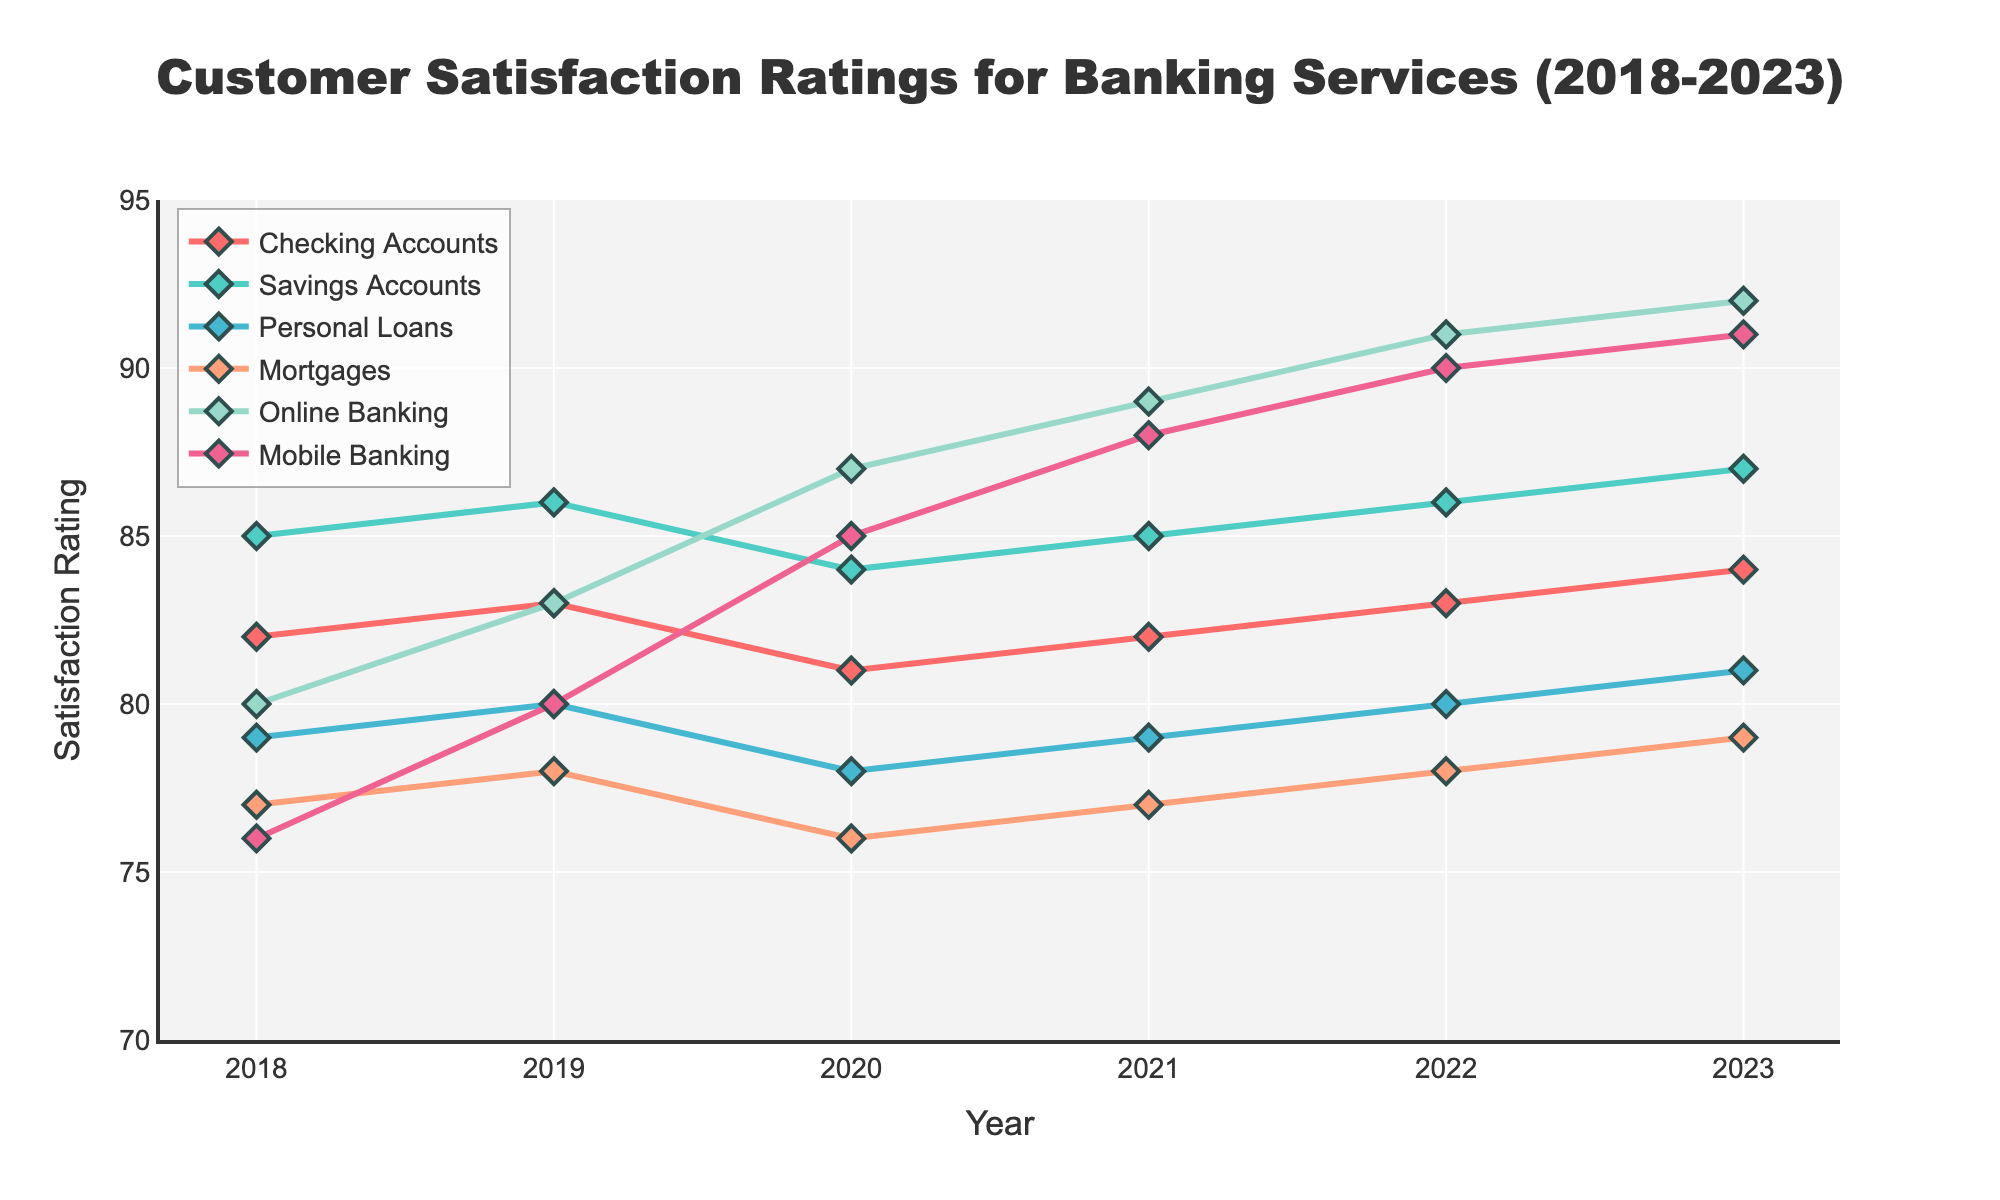What is the satisfaction rating for Online Banking in 2020? Look for the data point corresponding to Online Banking in 2020 in the chart. The rating is 87.
Answer: 87 Which service had the highest satisfaction rating in 2023? Examine the ratings for all services in 2023; the highest value is for Online Banking with a rating of 92.
Answer: Online Banking How much did the satisfaction rating for Personal Loans change from 2018 to 2023? Subtract the rating in 2018 (79) from the rating in 2023 (81). The change is 81 - 79 = 2.
Answer: 2 Which service experienced the largest increase in customer satisfaction from 2018 to 2023? Calculate the difference for each service between 2023 and 2018, then determine the largest increase. Online Banking had an increase from 80 to 92, which is 12 points.
Answer: Online Banking By how many points did the satisfaction rating for Mobile Banking increase between 2020 and 2021? Subtract the rating in 2020 (85) from the rating in 2021 (88). The increase is 88 - 85 = 3.
Answer: 3 What is the average satisfaction rating for Checking Accounts from 2018 to 2023? Sum the ratings from 2018 to 2023 (82 + 83 + 81 + 82 + 83 + 84) and divide by the number of years (6). The average is (82 + 83 + 81 + 82 + 83 + 84) / 6 = 82.5.
Answer: 82.5 Did the satisfaction rating for Mortgages ever drop below 77 between 2018 and 2023? Check the ratings for Mortgages in each year; the lowest rating is 76 in 2020.
Answer: Yes Which two services had the closest satisfaction ratings in 2019? Compare the ratings for all services in 2019. Savings Accounts (86) and Checking Accounts (83) are closest with a difference of 3.
Answer: Checking Accounts and Savings Accounts How did the satisfaction rating for Savings Accounts change in 2021 compared to 2020? Subtract the rating in 2020 (84) from the rating in 2021 (85). The change is 85 - 84 = 1.
Answer: 1 What is the trend for Mobile Banking satisfaction ratings from 2018 to 2023? Observe the ratings for Mobile Banking across the years and note the general direction. The ratings increase steadily from 76 in 2018 to 91 in 2023.
Answer: Increasing 